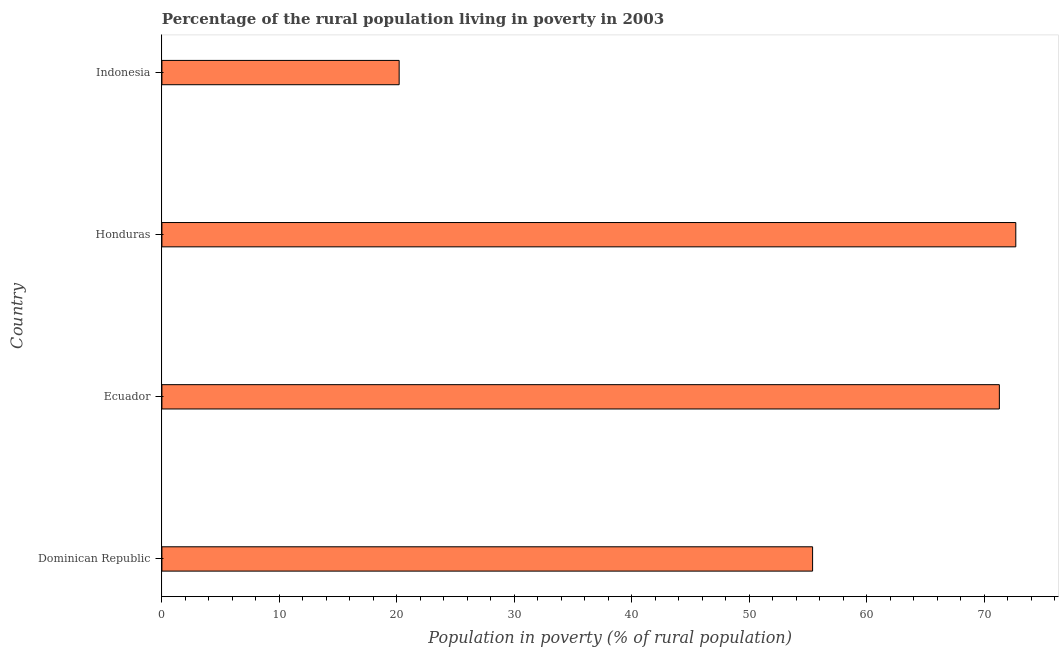What is the title of the graph?
Make the answer very short. Percentage of the rural population living in poverty in 2003. What is the label or title of the X-axis?
Ensure brevity in your answer.  Population in poverty (% of rural population). What is the percentage of rural population living below poverty line in Indonesia?
Your answer should be very brief. 20.2. Across all countries, what is the maximum percentage of rural population living below poverty line?
Your answer should be compact. 72.7. Across all countries, what is the minimum percentage of rural population living below poverty line?
Your answer should be compact. 20.2. In which country was the percentage of rural population living below poverty line maximum?
Make the answer very short. Honduras. In which country was the percentage of rural population living below poverty line minimum?
Your answer should be compact. Indonesia. What is the sum of the percentage of rural population living below poverty line?
Your response must be concise. 219.6. What is the difference between the percentage of rural population living below poverty line in Dominican Republic and Ecuador?
Ensure brevity in your answer.  -15.9. What is the average percentage of rural population living below poverty line per country?
Offer a very short reply. 54.9. What is the median percentage of rural population living below poverty line?
Offer a very short reply. 63.35. In how many countries, is the percentage of rural population living below poverty line greater than 4 %?
Provide a short and direct response. 4. What is the ratio of the percentage of rural population living below poverty line in Dominican Republic to that in Honduras?
Your answer should be compact. 0.76. Is the percentage of rural population living below poverty line in Ecuador less than that in Honduras?
Ensure brevity in your answer.  Yes. Is the difference between the percentage of rural population living below poverty line in Ecuador and Honduras greater than the difference between any two countries?
Your answer should be compact. No. What is the difference between the highest and the lowest percentage of rural population living below poverty line?
Your answer should be compact. 52.5. How many countries are there in the graph?
Offer a terse response. 4. What is the Population in poverty (% of rural population) of Dominican Republic?
Give a very brief answer. 55.4. What is the Population in poverty (% of rural population) of Ecuador?
Your response must be concise. 71.3. What is the Population in poverty (% of rural population) in Honduras?
Provide a short and direct response. 72.7. What is the Population in poverty (% of rural population) of Indonesia?
Your answer should be compact. 20.2. What is the difference between the Population in poverty (% of rural population) in Dominican Republic and Ecuador?
Provide a short and direct response. -15.9. What is the difference between the Population in poverty (% of rural population) in Dominican Republic and Honduras?
Offer a very short reply. -17.3. What is the difference between the Population in poverty (% of rural population) in Dominican Republic and Indonesia?
Offer a terse response. 35.2. What is the difference between the Population in poverty (% of rural population) in Ecuador and Honduras?
Ensure brevity in your answer.  -1.4. What is the difference between the Population in poverty (% of rural population) in Ecuador and Indonesia?
Keep it short and to the point. 51.1. What is the difference between the Population in poverty (% of rural population) in Honduras and Indonesia?
Give a very brief answer. 52.5. What is the ratio of the Population in poverty (% of rural population) in Dominican Republic to that in Ecuador?
Ensure brevity in your answer.  0.78. What is the ratio of the Population in poverty (% of rural population) in Dominican Republic to that in Honduras?
Make the answer very short. 0.76. What is the ratio of the Population in poverty (% of rural population) in Dominican Republic to that in Indonesia?
Give a very brief answer. 2.74. What is the ratio of the Population in poverty (% of rural population) in Ecuador to that in Honduras?
Provide a short and direct response. 0.98. What is the ratio of the Population in poverty (% of rural population) in Ecuador to that in Indonesia?
Keep it short and to the point. 3.53. What is the ratio of the Population in poverty (% of rural population) in Honduras to that in Indonesia?
Your response must be concise. 3.6. 